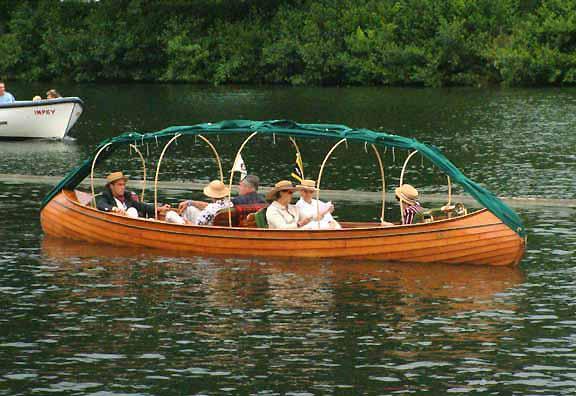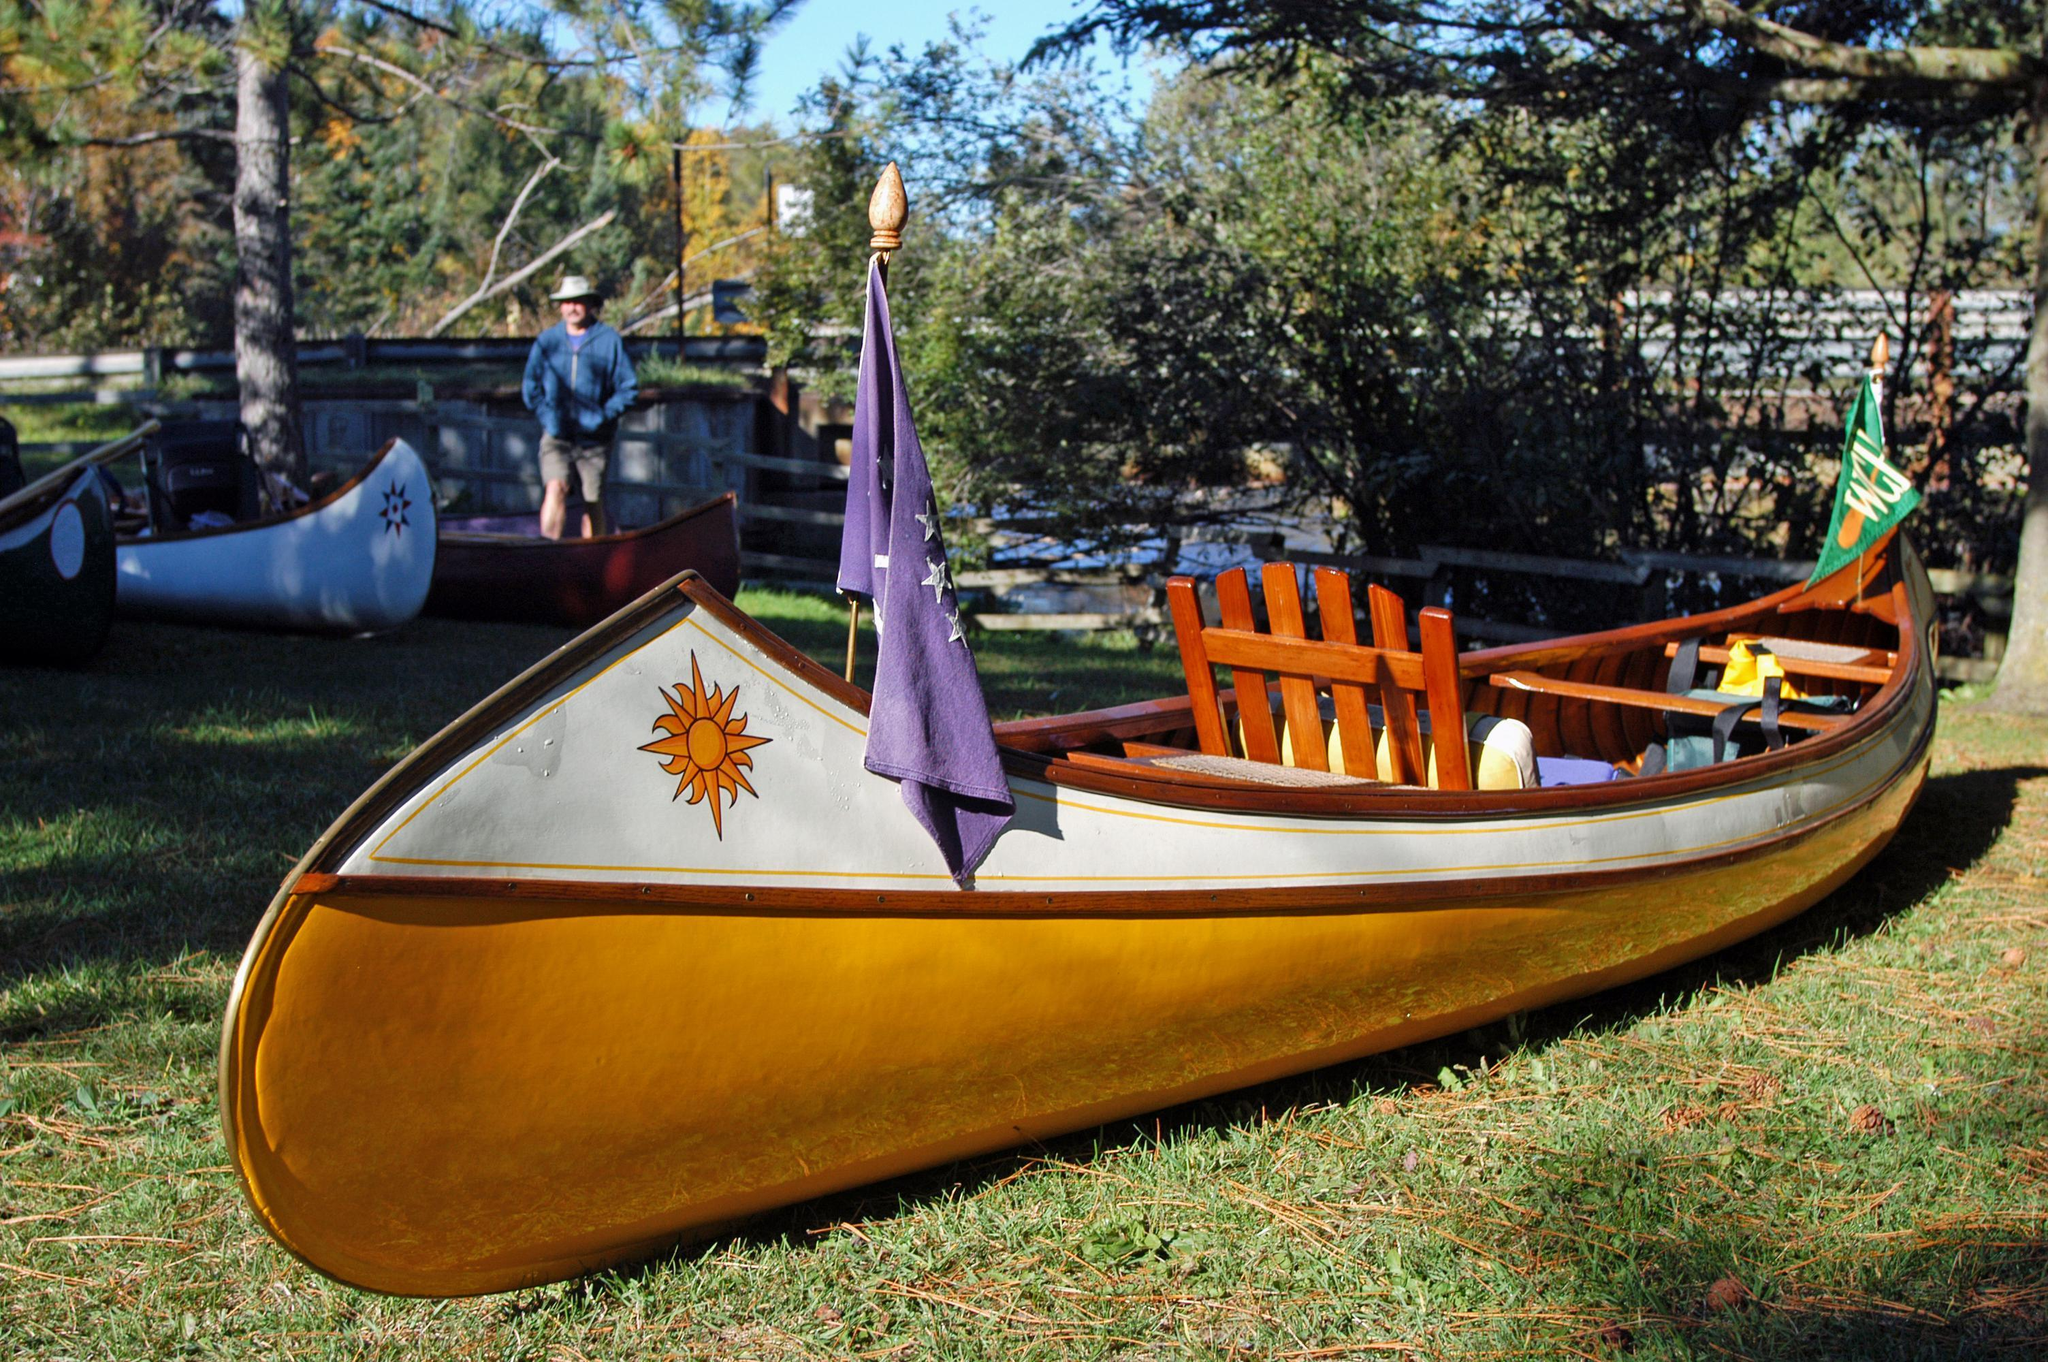The first image is the image on the left, the second image is the image on the right. Considering the images on both sides, is "An image shows exactly one canoe sitting in the water." valid? Answer yes or no. Yes. The first image is the image on the left, the second image is the image on the right. Given the left and right images, does the statement "The left image shows one or more people inside a brown canoe that has a green top visible on it" hold true? Answer yes or no. Yes. 